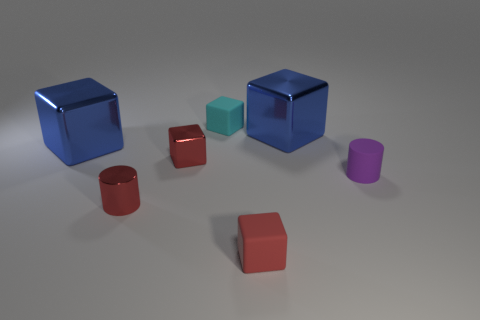Subtract all small red metallic blocks. How many blocks are left? 4 Subtract all gray cubes. Subtract all yellow spheres. How many cubes are left? 5 Add 2 big gray spheres. How many objects exist? 9 Subtract all cylinders. How many objects are left? 5 Add 2 red cylinders. How many red cylinders are left? 3 Add 3 large blue cubes. How many large blue cubes exist? 5 Subtract 2 blue blocks. How many objects are left? 5 Subtract all small green metallic things. Subtract all tiny cyan cubes. How many objects are left? 6 